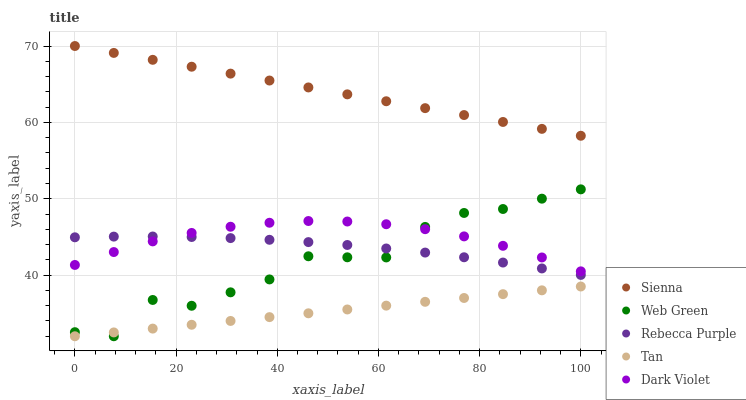Does Tan have the minimum area under the curve?
Answer yes or no. Yes. Does Sienna have the maximum area under the curve?
Answer yes or no. Yes. Does Dark Violet have the minimum area under the curve?
Answer yes or no. No. Does Dark Violet have the maximum area under the curve?
Answer yes or no. No. Is Tan the smoothest?
Answer yes or no. Yes. Is Web Green the roughest?
Answer yes or no. Yes. Is Dark Violet the smoothest?
Answer yes or no. No. Is Dark Violet the roughest?
Answer yes or no. No. Does Tan have the lowest value?
Answer yes or no. Yes. Does Dark Violet have the lowest value?
Answer yes or no. No. Does Sienna have the highest value?
Answer yes or no. Yes. Does Dark Violet have the highest value?
Answer yes or no. No. Is Rebecca Purple less than Sienna?
Answer yes or no. Yes. Is Sienna greater than Web Green?
Answer yes or no. Yes. Does Rebecca Purple intersect Dark Violet?
Answer yes or no. Yes. Is Rebecca Purple less than Dark Violet?
Answer yes or no. No. Is Rebecca Purple greater than Dark Violet?
Answer yes or no. No. Does Rebecca Purple intersect Sienna?
Answer yes or no. No. 